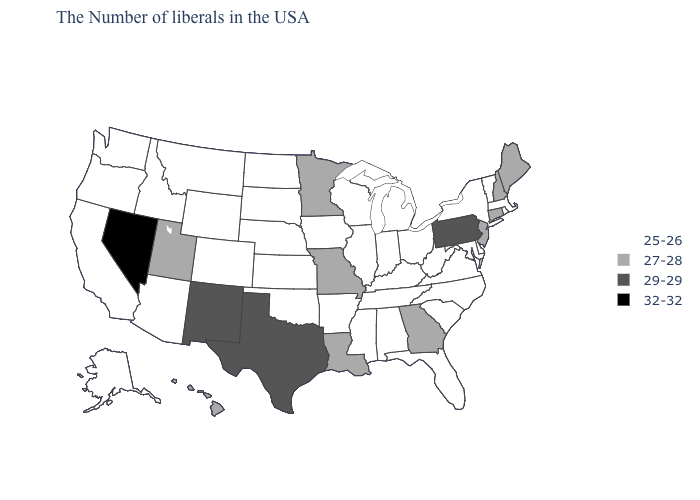Among the states that border Montana , which have the lowest value?
Short answer required. South Dakota, North Dakota, Wyoming, Idaho. Does the map have missing data?
Quick response, please. No. What is the value of Utah?
Write a very short answer. 27-28. Name the states that have a value in the range 32-32?
Quick response, please. Nevada. What is the value of Connecticut?
Concise answer only. 27-28. Among the states that border Louisiana , which have the lowest value?
Quick response, please. Mississippi, Arkansas. Among the states that border Texas , which have the highest value?
Write a very short answer. New Mexico. What is the value of Florida?
Give a very brief answer. 25-26. Among the states that border South Carolina , which have the lowest value?
Answer briefly. North Carolina. Does Nevada have the lowest value in the West?
Short answer required. No. How many symbols are there in the legend?
Quick response, please. 4. Which states hav the highest value in the South?
Answer briefly. Texas. Does New York have a lower value than New Jersey?
Concise answer only. Yes. What is the value of Wyoming?
Answer briefly. 25-26. What is the value of Rhode Island?
Keep it brief. 25-26. 